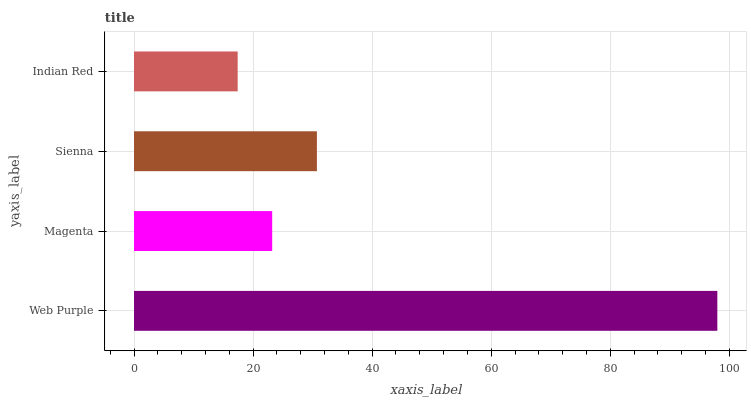Is Indian Red the minimum?
Answer yes or no. Yes. Is Web Purple the maximum?
Answer yes or no. Yes. Is Magenta the minimum?
Answer yes or no. No. Is Magenta the maximum?
Answer yes or no. No. Is Web Purple greater than Magenta?
Answer yes or no. Yes. Is Magenta less than Web Purple?
Answer yes or no. Yes. Is Magenta greater than Web Purple?
Answer yes or no. No. Is Web Purple less than Magenta?
Answer yes or no. No. Is Sienna the high median?
Answer yes or no. Yes. Is Magenta the low median?
Answer yes or no. Yes. Is Magenta the high median?
Answer yes or no. No. Is Web Purple the low median?
Answer yes or no. No. 